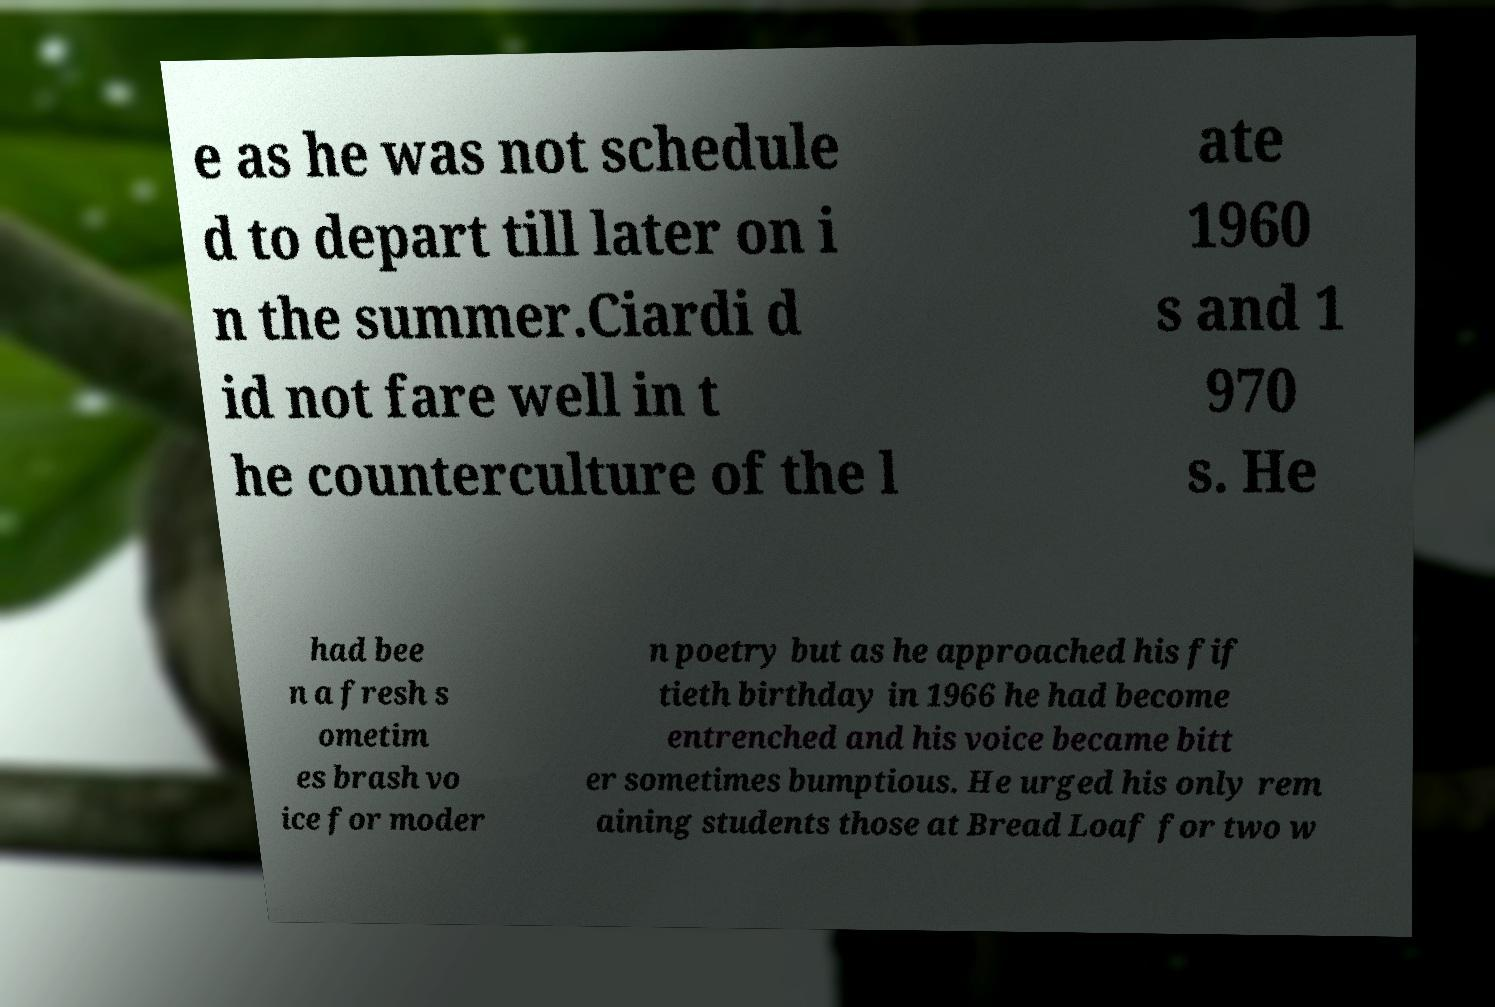Please identify and transcribe the text found in this image. e as he was not schedule d to depart till later on i n the summer.Ciardi d id not fare well in t he counterculture of the l ate 1960 s and 1 970 s. He had bee n a fresh s ometim es brash vo ice for moder n poetry but as he approached his fif tieth birthday in 1966 he had become entrenched and his voice became bitt er sometimes bumptious. He urged his only rem aining students those at Bread Loaf for two w 